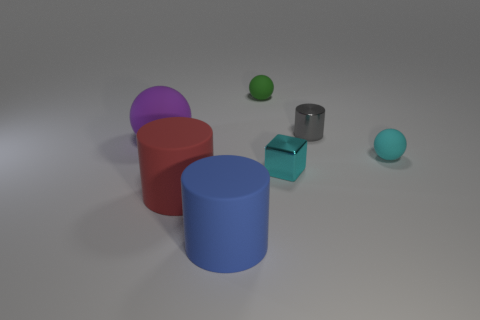Are the green sphere and the small cyan thing to the left of the small gray cylinder made of the same material?
Ensure brevity in your answer.  No. There is a object that is both behind the purple rubber sphere and right of the tiny cyan block; what is its material?
Your answer should be very brief. Metal. What color is the ball to the right of the small matte object to the left of the tiny gray cylinder?
Provide a short and direct response. Cyan. There is a cylinder that is behind the big purple object; what material is it?
Ensure brevity in your answer.  Metal. Is the number of tiny green metallic cylinders less than the number of small cyan balls?
Your answer should be compact. Yes. There is a green thing; does it have the same shape as the large purple matte object in front of the tiny gray metallic cylinder?
Your answer should be very brief. Yes. The object that is both on the left side of the blue matte cylinder and behind the small cyan metallic object has what shape?
Provide a short and direct response. Sphere. Is the number of small things that are behind the green matte ball the same as the number of large cylinders that are in front of the big red matte cylinder?
Give a very brief answer. No. Is the shape of the tiny metal object behind the large purple matte object the same as  the large blue rubber thing?
Keep it short and to the point. Yes. How many gray things are either small metallic objects or small things?
Your answer should be compact. 1. 